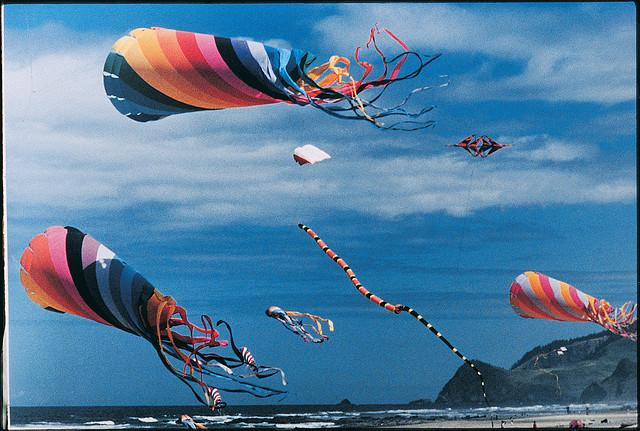What do the kites resemble?

Choices:
A) squid
B) tiger
C) dog
D) monkey squid 